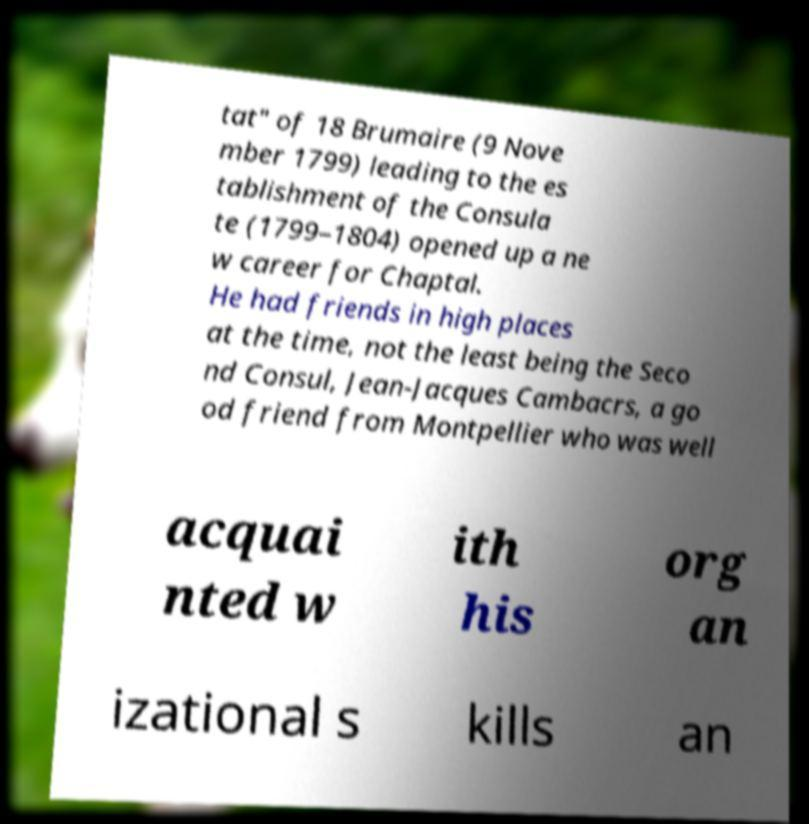Please identify and transcribe the text found in this image. tat" of 18 Brumaire (9 Nove mber 1799) leading to the es tablishment of the Consula te (1799–1804) opened up a ne w career for Chaptal. He had friends in high places at the time, not the least being the Seco nd Consul, Jean-Jacques Cambacrs, a go od friend from Montpellier who was well acquai nted w ith his org an izational s kills an 